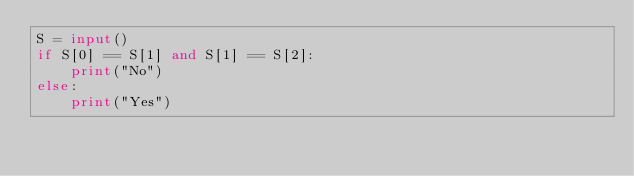<code> <loc_0><loc_0><loc_500><loc_500><_Python_>S = input()
if S[0] == S[1] and S[1] == S[2]:
    print("No")
else:
    print("Yes")</code> 